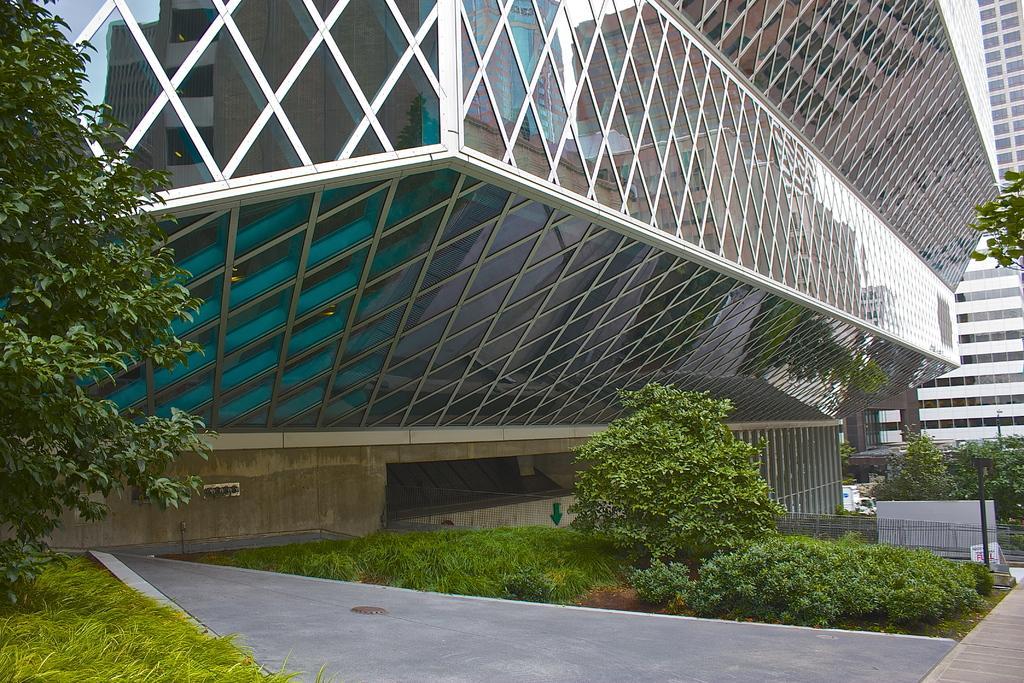Could you give a brief overview of what you see in this image? In this image in the center there are buildings and some trees, poles, wall. And at the bottom there is grass and some plants and walkway, and there is a railing. 